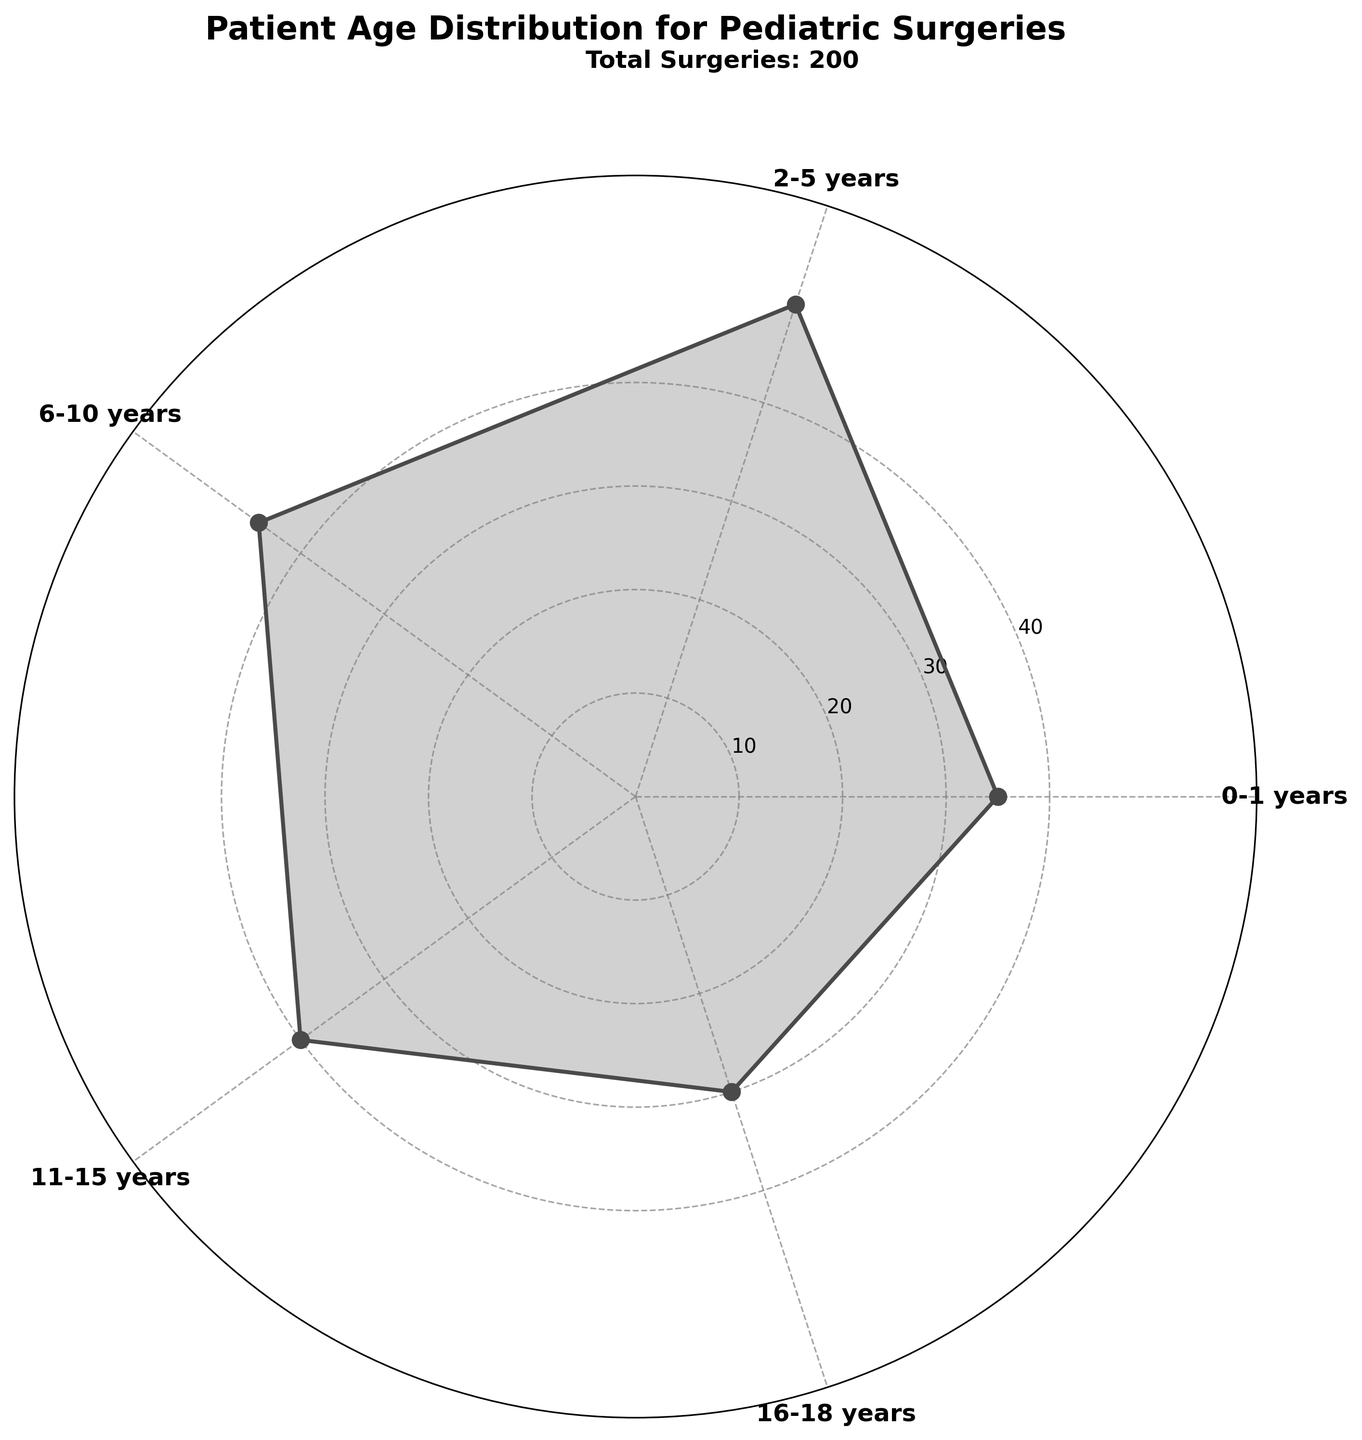What is the title of the figure? The title is placed at the top of the figure and reads "Patient Age Distribution for Pediatric Surgeries."
Answer: Patient Age Distribution for Pediatric Surgeries How many age groups are represented in the figure? Each segment in the polar chart represents an age group, and there are five segments labeled with age groups from "0-1 years" to "16-18 years."
Answer: 5 Which age group has the highest number of surgeries? By looking at the highest point on the chart, you can see that the age group "2-5 years" has the highest number of surgeries, represented by the longest segment.
Answer: 2-5 years What is the total number of surgeries represented in the figure? The plot annotation specifies this value as "Total Surgeries: 200." Alternatively, summing the surgeries given in each age group (35 + 50 + 45 + 40 + 30) equals 200.
Answer: 200 What is the average number of surgeries per age group? Divide the total number of surgeries (200) by the number of age groups (5): 200 / 5 = 40.
Answer: 40 What is the difference in the number of surgeries between the age group 0-1 years and 16-18 years? Subtract the number of surgeries for the age group "16-18 years" (30) from the number of surgeries for the age group "0-1 years" (35): 35 - 30 = 5.
Answer: 5 Which two age groups have the closest number of surgeries, and what is the difference between them? By comparing the number of surgeries of each age group: "0-1 years" (35), "2-5 years" (50), "6-10 years" (45), "11-15 years" (40), "16-18 years" (30), the age groups "0-1 years" and "11-15 years" have the closest numbers with a difference of 35 - 40 = 5.
Answer: 0-1 years and 11-15 years, 5 How does the number of surgeries change from the youngest age group to the oldest? The number of surgeries starts at 35 for "0-1 years," increases to a peak of 50 for "2-5 years," then gradually decreases through "6-10 years" (45), "11-15 years" (40), and finally to 30 for "16-18 years."
Answer: Increases then decreases Which age group shows a 40 surgeries count and where is it placed on the plot? By finding the segment corresponding to the 40 count, it is seen that the age group "11-15 years" is placed appropriately in the middle of the chart segments.
Answer: 11-15 years, middle What age groups have fewer surgeries than the age group "6-10 years"? From the chart, "6-10 years" has 45 surgeries. Age groups with fewer surgeries are "0-1 years" (35), "11-15 years" (40), and "16-18 years" (30).
Answer: 0-1 years, 11-15 years, 16-18 years 